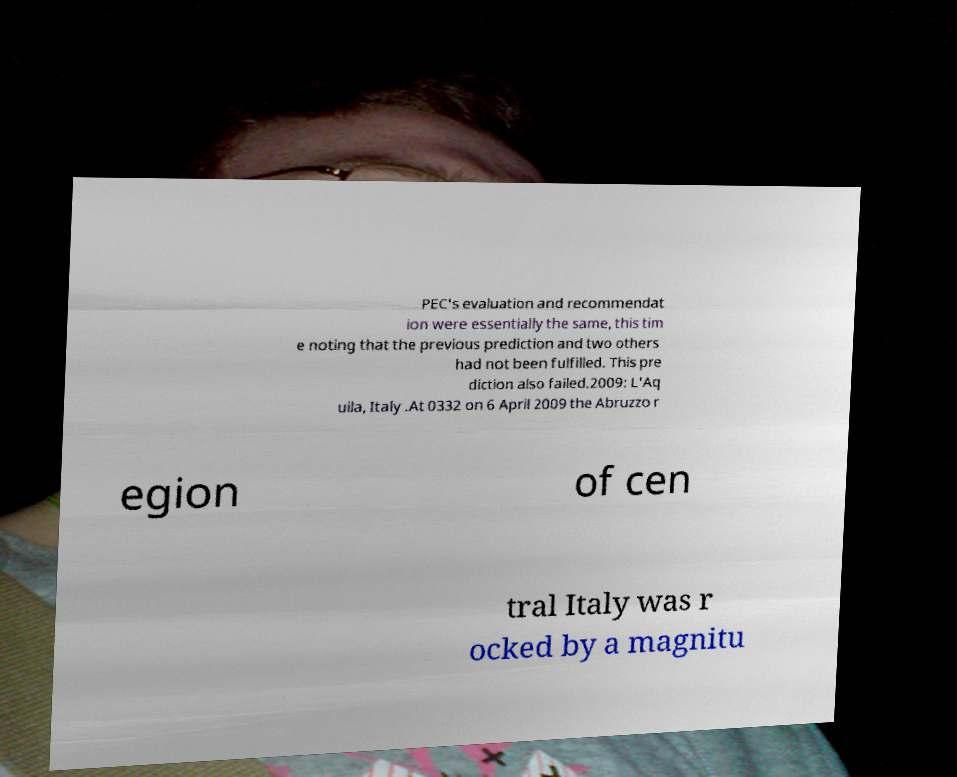For documentation purposes, I need the text within this image transcribed. Could you provide that? PEC's evaluation and recommendat ion were essentially the same, this tim e noting that the previous prediction and two others had not been fulfilled. This pre diction also failed.2009: L'Aq uila, Italy .At 0332 on 6 April 2009 the Abruzzo r egion of cen tral Italy was r ocked by a magnitu 